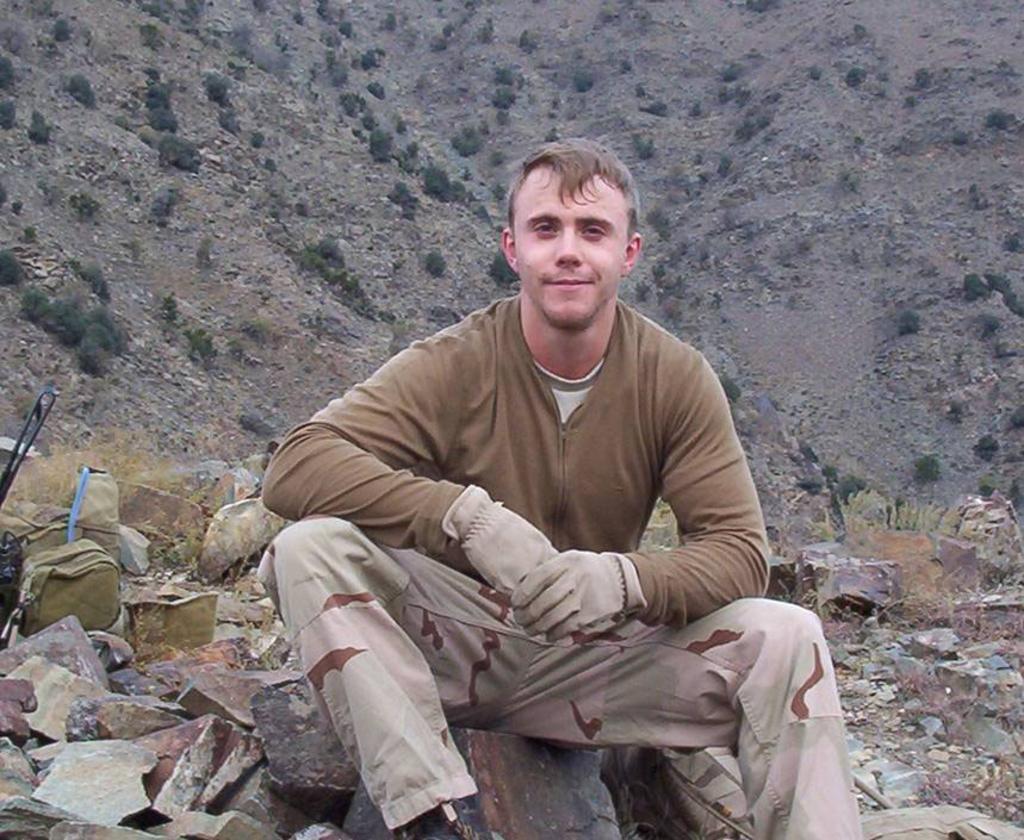Describe this image in one or two sentences. In this image we can see a person is sitting, there are rocks, bag, also we can see plants, and the mountain. 